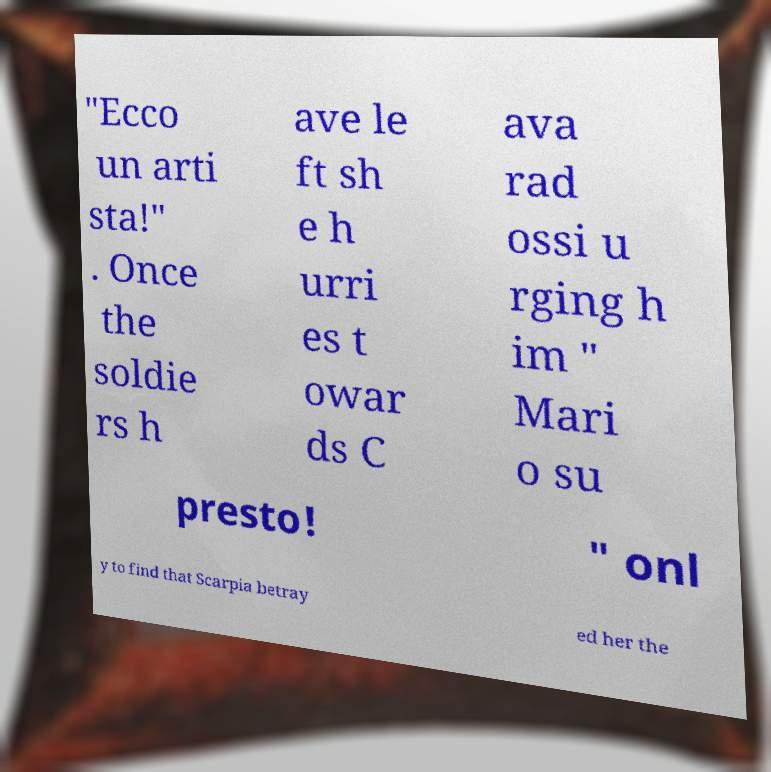Could you assist in decoding the text presented in this image and type it out clearly? "Ecco un arti sta!" . Once the soldie rs h ave le ft sh e h urri es t owar ds C ava rad ossi u rging h im " Mari o su presto! " onl y to find that Scarpia betray ed her the 